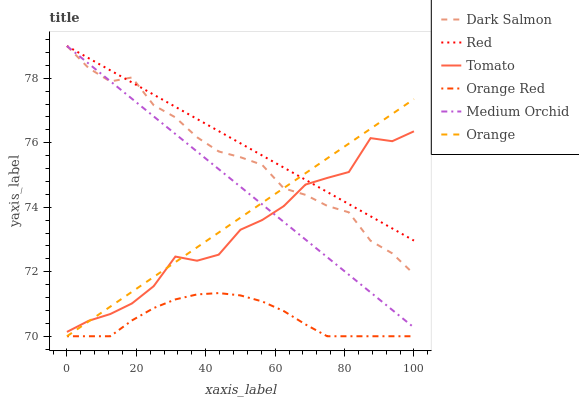Does Orange Red have the minimum area under the curve?
Answer yes or no. Yes. Does Red have the maximum area under the curve?
Answer yes or no. Yes. Does Medium Orchid have the minimum area under the curve?
Answer yes or no. No. Does Medium Orchid have the maximum area under the curve?
Answer yes or no. No. Is Medium Orchid the smoothest?
Answer yes or no. Yes. Is Tomato the roughest?
Answer yes or no. Yes. Is Dark Salmon the smoothest?
Answer yes or no. No. Is Dark Salmon the roughest?
Answer yes or no. No. Does Orange have the lowest value?
Answer yes or no. Yes. Does Medium Orchid have the lowest value?
Answer yes or no. No. Does Red have the highest value?
Answer yes or no. Yes. Does Orange have the highest value?
Answer yes or no. No. Is Orange Red less than Tomato?
Answer yes or no. Yes. Is Red greater than Orange Red?
Answer yes or no. Yes. Does Orange Red intersect Orange?
Answer yes or no. Yes. Is Orange Red less than Orange?
Answer yes or no. No. Is Orange Red greater than Orange?
Answer yes or no. No. Does Orange Red intersect Tomato?
Answer yes or no. No. 